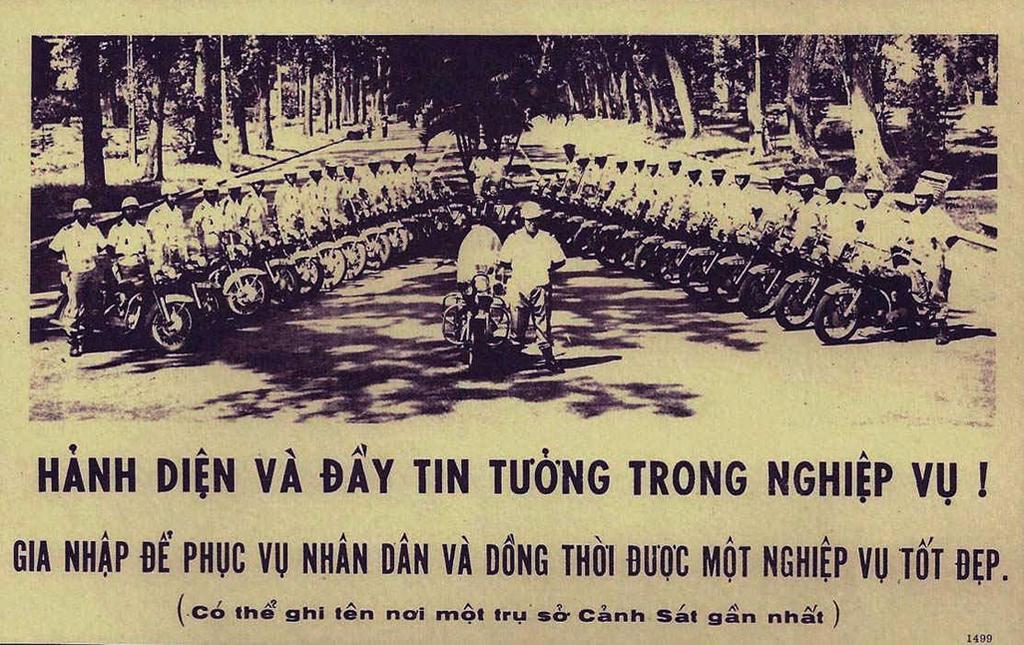Could you give a brief overview of what you see in this image? In this picture I can see a paper in front, on which I see a picture on which there are number of bikes and people near to it and in the background I see number of trees and on the bottom of this picture I see something is written. 